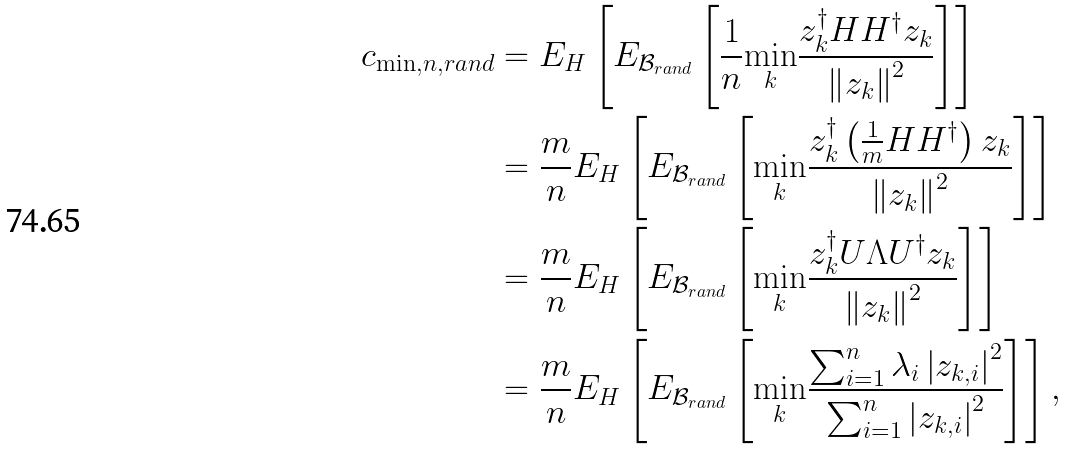Convert formula to latex. <formula><loc_0><loc_0><loc_500><loc_500>c _ { \min , n , r a n d } & = E _ { H } \left [ E _ { \mathcal { B } _ { r a n d } } \left [ \frac { 1 } { n } \underset { k } { \min } \frac { z _ { k } ^ { \dagger } H H ^ { \dagger } z _ { k } } { \left \| z _ { k } \right \| ^ { 2 } } \right ] \right ] \\ & = \frac { m } { n } E _ { H } \left [ E _ { \mathcal { B } _ { r a n d } } \left [ \underset { k } { \min } \frac { z _ { k } ^ { \dagger } \left ( \frac { 1 } { m } H H ^ { \dagger } \right ) z _ { k } } { \left \| z _ { k } \right \| ^ { 2 } } \right ] \right ] \\ & = \frac { m } { n } E _ { H } \left [ E _ { \mathcal { B } _ { r a n d } } \left [ \underset { k } { \min } \frac { z _ { k } ^ { \dagger } U \Lambda U ^ { \dagger } z _ { k } } { \left \| z _ { k } \right \| ^ { 2 } } \right ] \right ] \\ & = \frac { m } { n } E _ { H } \left [ E _ { \mathcal { B } _ { r a n d } } \left [ \underset { k } { \min } \frac { \sum _ { i = 1 } ^ { n } \lambda _ { i } \left | z _ { k , i } \right | ^ { 2 } } { \sum _ { i = 1 } ^ { n } \left | z _ { k , i } \right | ^ { 2 } } \right ] \right ] ,</formula> 